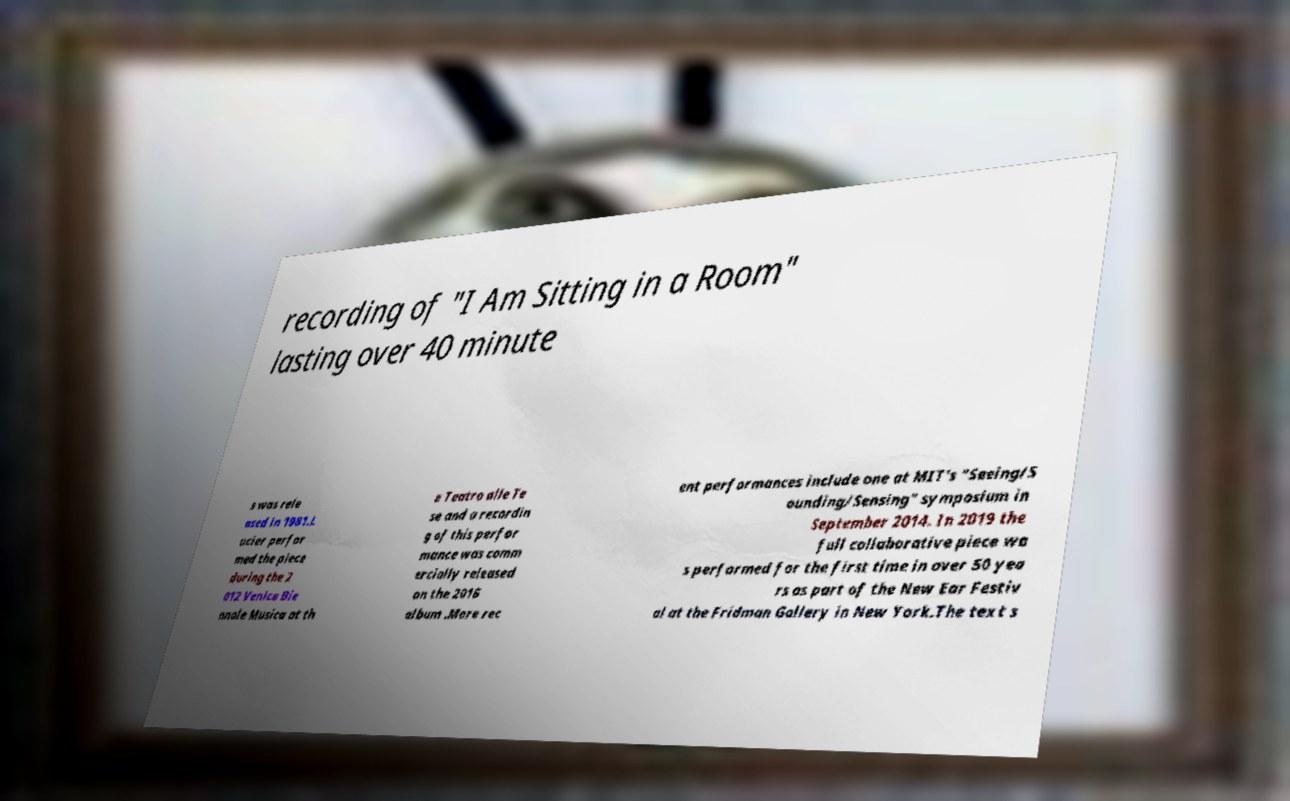Please read and relay the text visible in this image. What does it say? recording of "I Am Sitting in a Room" lasting over 40 minute s was rele ased in 1981.L ucier perfor med the piece during the 2 012 Venice Bie nnale Musica at th e Teatro alle Te se and a recordin g of this perfor mance was comm ercially released on the 2016 album .More rec ent performances include one at MIT's "Seeing/S ounding/Sensing" symposium in September 2014. In 2019 the full collaborative piece wa s performed for the first time in over 50 yea rs as part of the New Ear Festiv al at the Fridman Gallery in New York.The text s 